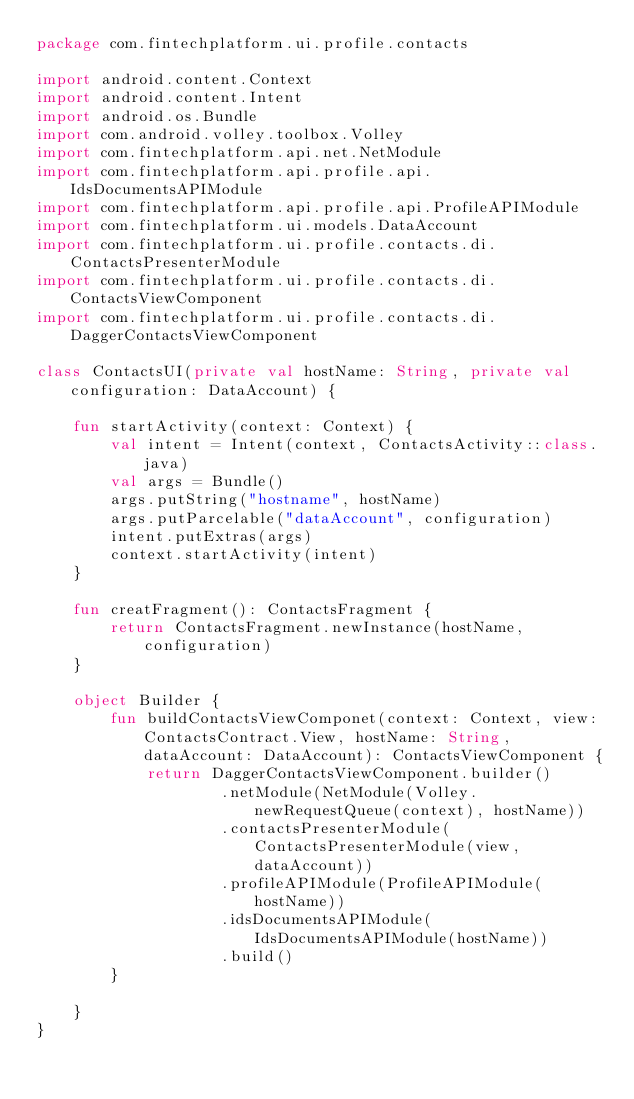Convert code to text. <code><loc_0><loc_0><loc_500><loc_500><_Kotlin_>package com.fintechplatform.ui.profile.contacts

import android.content.Context
import android.content.Intent
import android.os.Bundle
import com.android.volley.toolbox.Volley
import com.fintechplatform.api.net.NetModule
import com.fintechplatform.api.profile.api.IdsDocumentsAPIModule
import com.fintechplatform.api.profile.api.ProfileAPIModule
import com.fintechplatform.ui.models.DataAccount
import com.fintechplatform.ui.profile.contacts.di.ContactsPresenterModule
import com.fintechplatform.ui.profile.contacts.di.ContactsViewComponent
import com.fintechplatform.ui.profile.contacts.di.DaggerContactsViewComponent

class ContactsUI(private val hostName: String, private val configuration: DataAccount) {

    fun startActivity(context: Context) {
        val intent = Intent(context, ContactsActivity::class.java)
        val args = Bundle()
        args.putString("hostname", hostName)
        args.putParcelable("dataAccount", configuration)
        intent.putExtras(args)
        context.startActivity(intent)
    }

    fun creatFragment(): ContactsFragment {
        return ContactsFragment.newInstance(hostName, configuration)
    }

    object Builder {
        fun buildContactsViewComponet(context: Context, view: ContactsContract.View, hostName: String, dataAccount: DataAccount): ContactsViewComponent {
            return DaggerContactsViewComponent.builder()
                    .netModule(NetModule(Volley.newRequestQueue(context), hostName))
                    .contactsPresenterModule(ContactsPresenterModule(view, dataAccount))
                    .profileAPIModule(ProfileAPIModule(hostName))
                    .idsDocumentsAPIModule(IdsDocumentsAPIModule(hostName))
                    .build()
        }

    }
}
</code> 